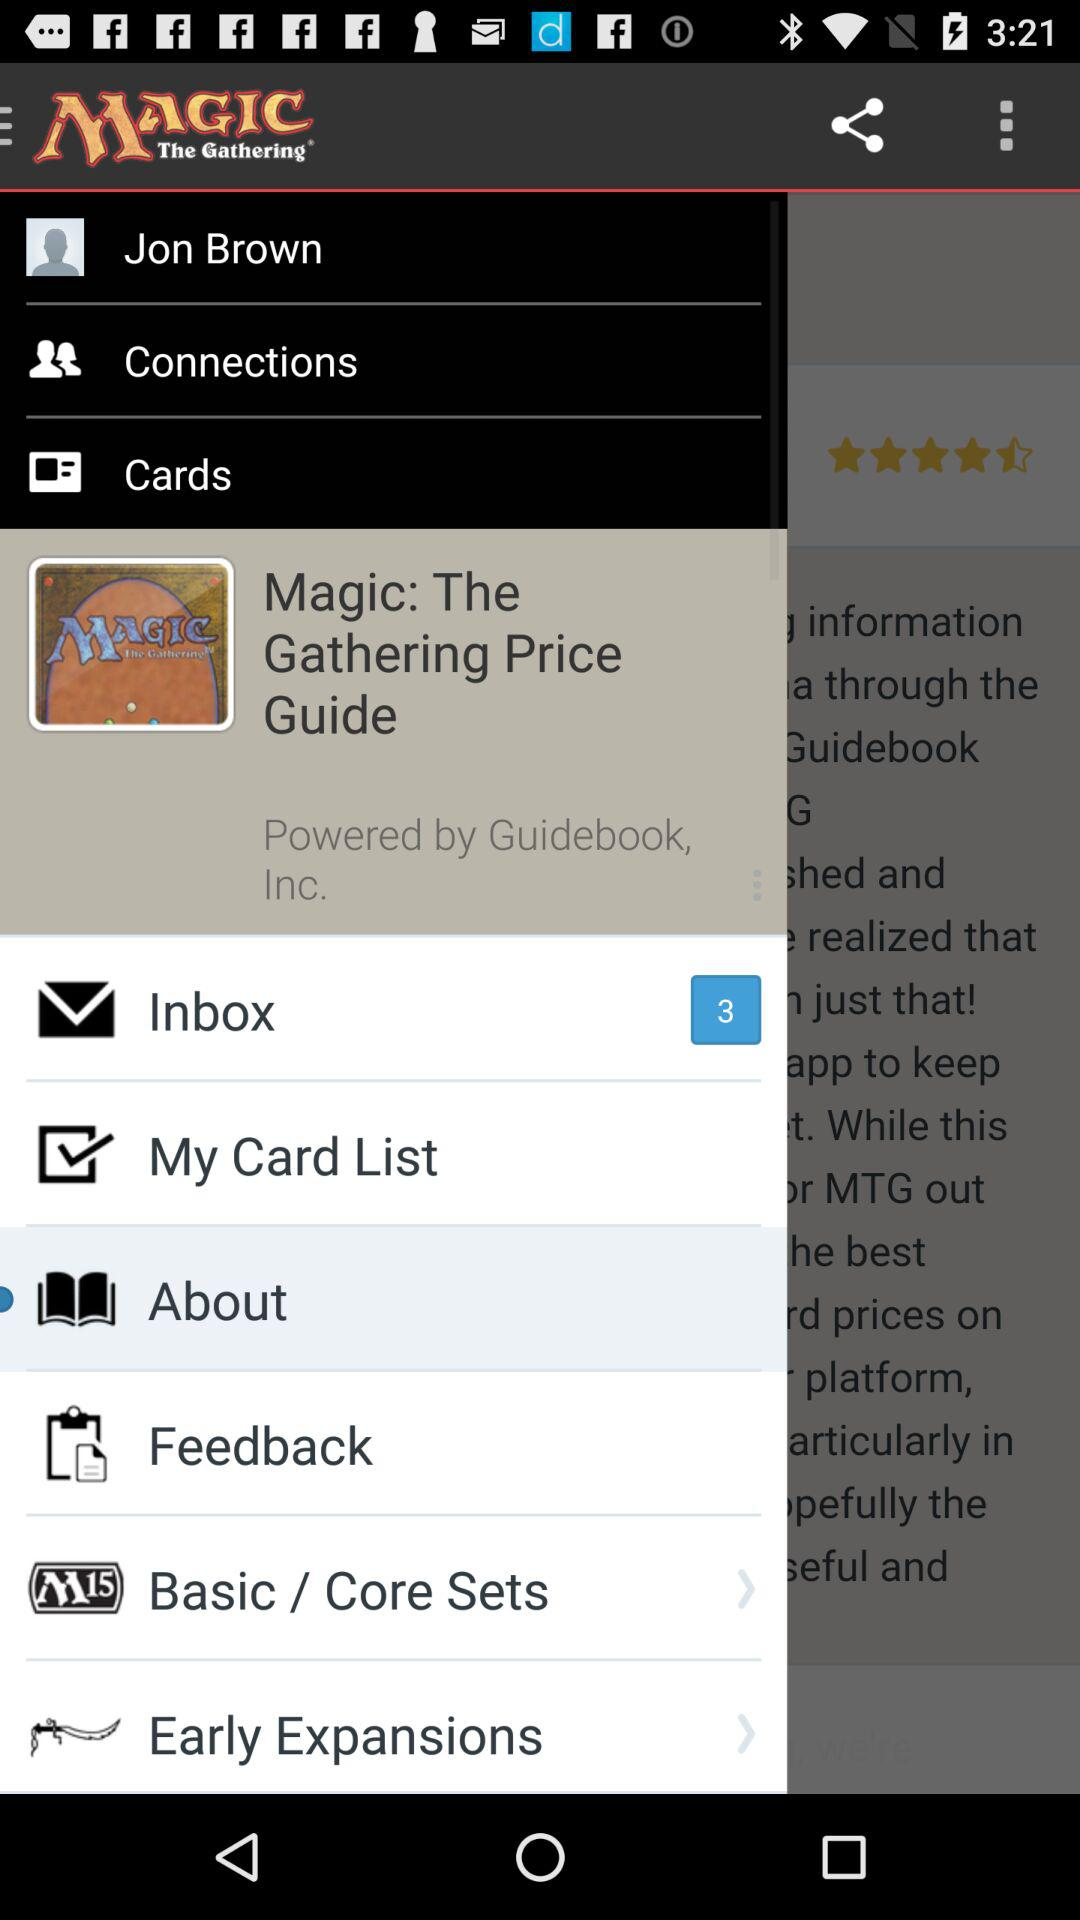What is the application name? The application name is "Magic: The Gathering Price Guide". 